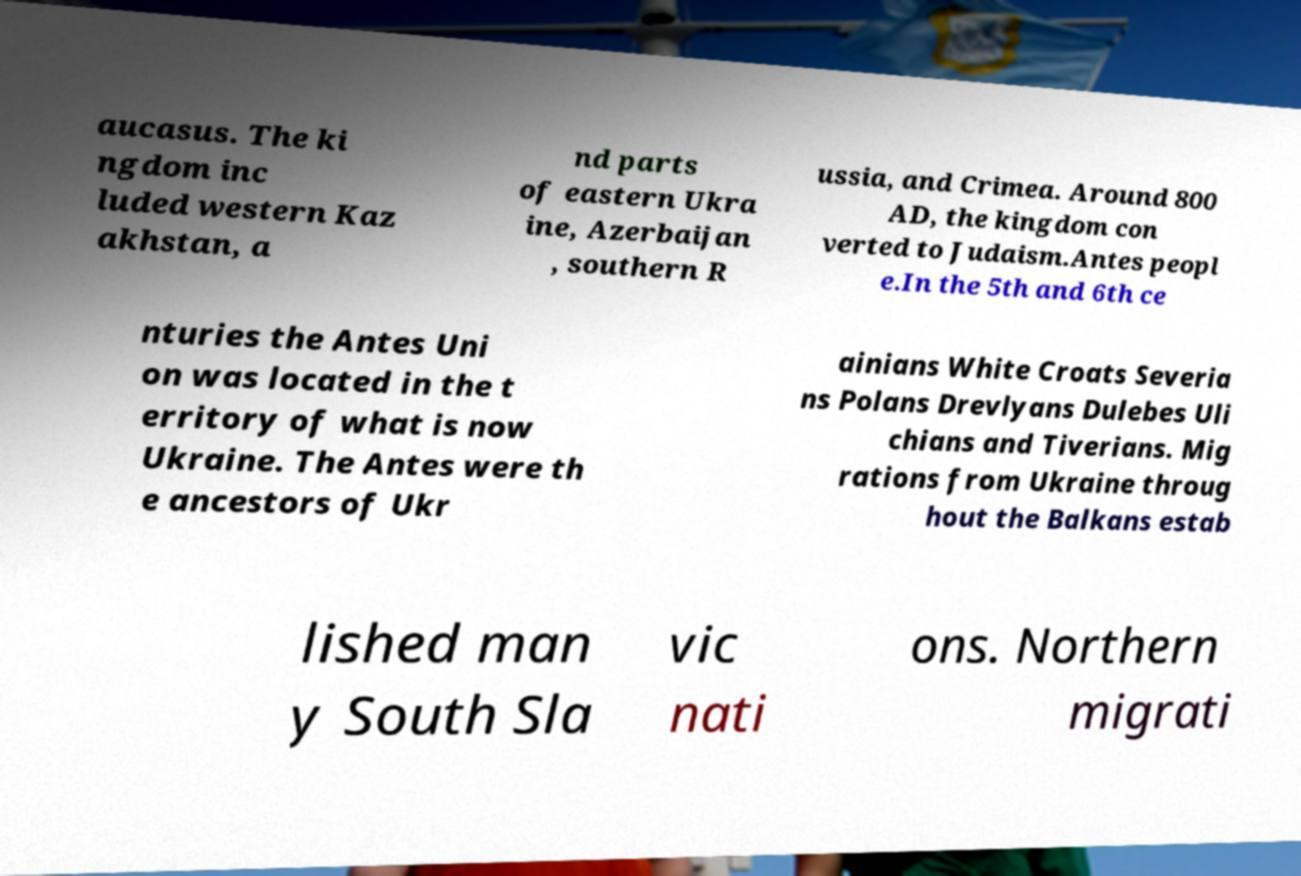Please read and relay the text visible in this image. What does it say? aucasus. The ki ngdom inc luded western Kaz akhstan, a nd parts of eastern Ukra ine, Azerbaijan , southern R ussia, and Crimea. Around 800 AD, the kingdom con verted to Judaism.Antes peopl e.In the 5th and 6th ce nturies the Antes Uni on was located in the t erritory of what is now Ukraine. The Antes were th e ancestors of Ukr ainians White Croats Severia ns Polans Drevlyans Dulebes Uli chians and Tiverians. Mig rations from Ukraine throug hout the Balkans estab lished man y South Sla vic nati ons. Northern migrati 